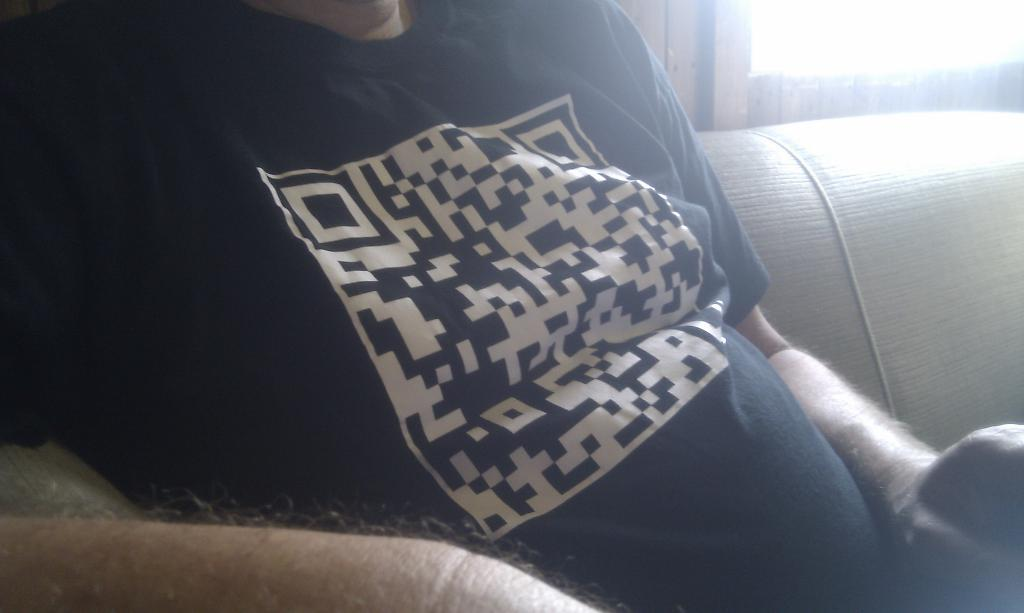What is the person in the image doing? The person is sitting on a sofa set in the image. Can you describe the lighting in the image? There is a light focus visible in the top right corner of the image. How many pigs are present in the image? There are no pigs present in the image. What offer is being made by the person in the image? The image does not show any offer being made, as it only depicts a person sitting on a sofa set. 